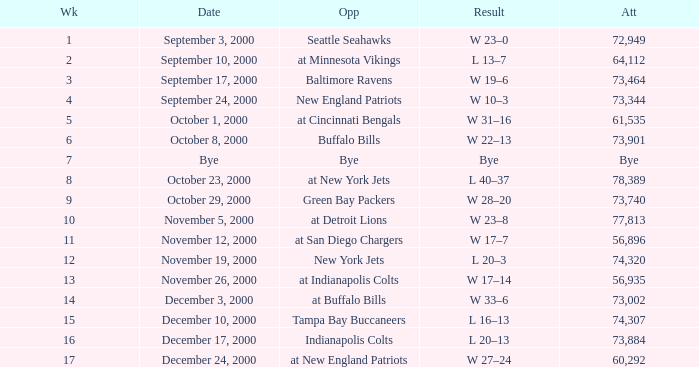What is the Result of the game against the Indianapolis Colts? L 20–13. 